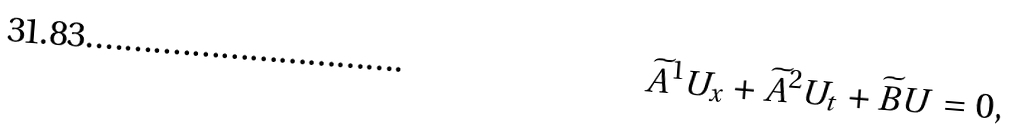Convert formula to latex. <formula><loc_0><loc_0><loc_500><loc_500>\widetilde { A } ^ { 1 } U _ { x } + \widetilde { A } ^ { 2 } U _ { t } + \widetilde { B } U = 0 ,</formula> 